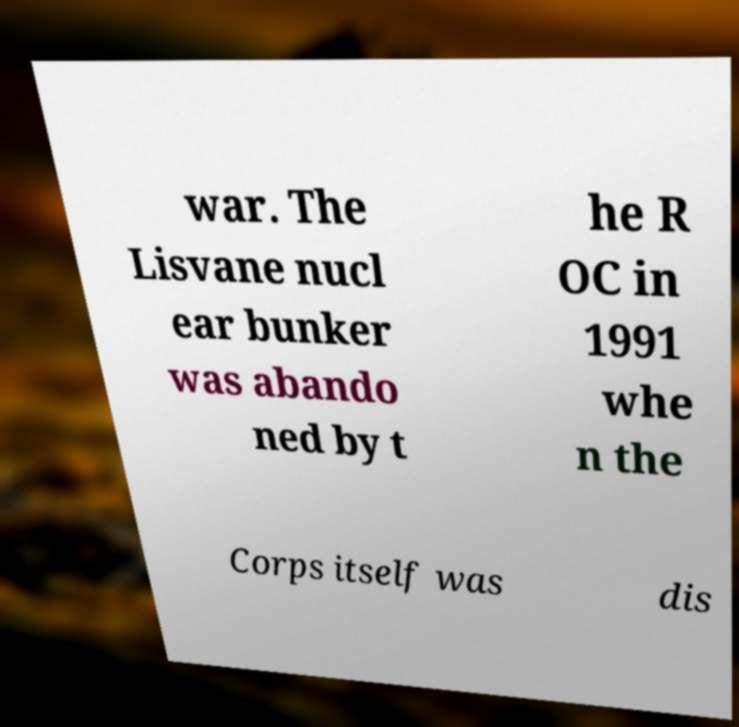Can you read and provide the text displayed in the image?This photo seems to have some interesting text. Can you extract and type it out for me? war. The Lisvane nucl ear bunker was abando ned by t he R OC in 1991 whe n the Corps itself was dis 